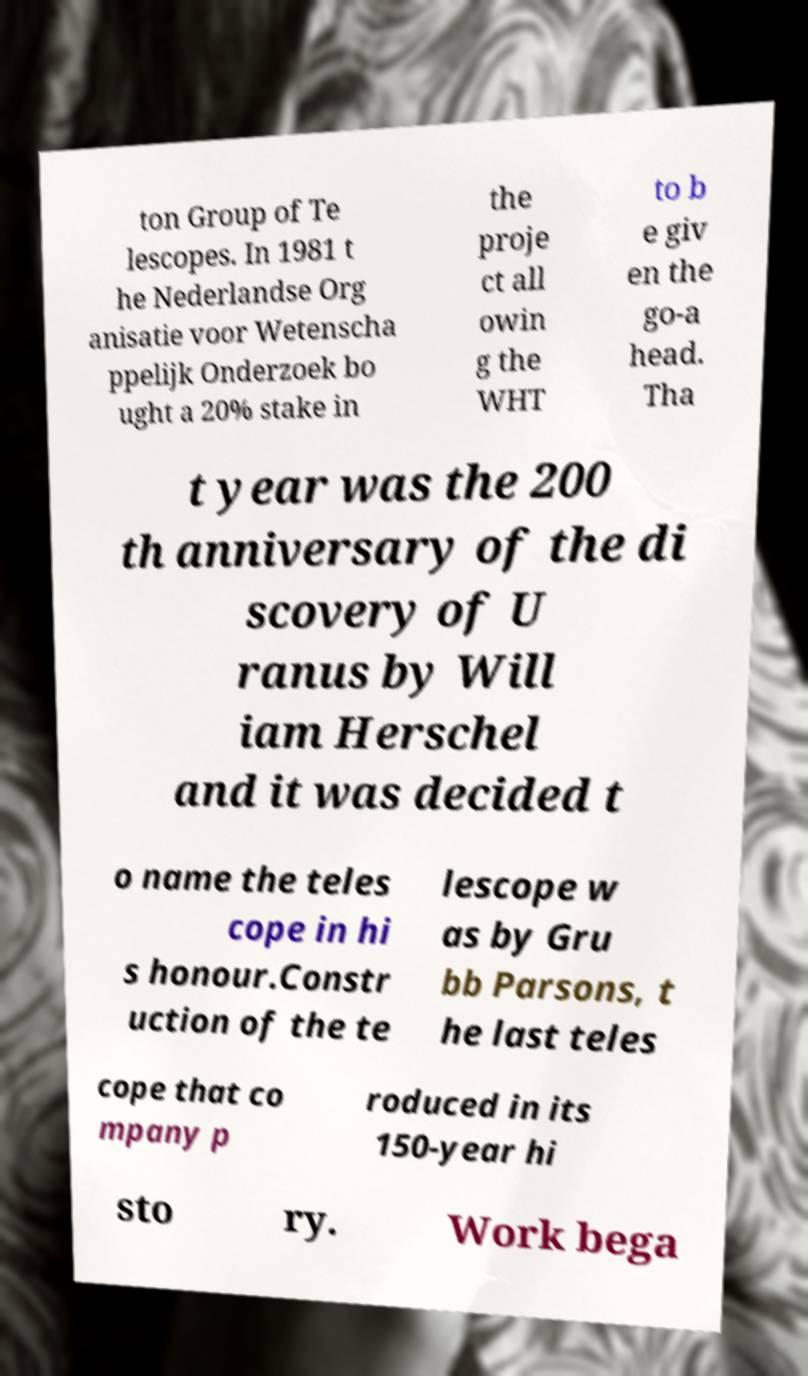Please identify and transcribe the text found in this image. ton Group of Te lescopes. In 1981 t he Nederlandse Org anisatie voor Wetenscha ppelijk Onderzoek bo ught a 20% stake in the proje ct all owin g the WHT to b e giv en the go-a head. Tha t year was the 200 th anniversary of the di scovery of U ranus by Will iam Herschel and it was decided t o name the teles cope in hi s honour.Constr uction of the te lescope w as by Gru bb Parsons, t he last teles cope that co mpany p roduced in its 150-year hi sto ry. Work bega 